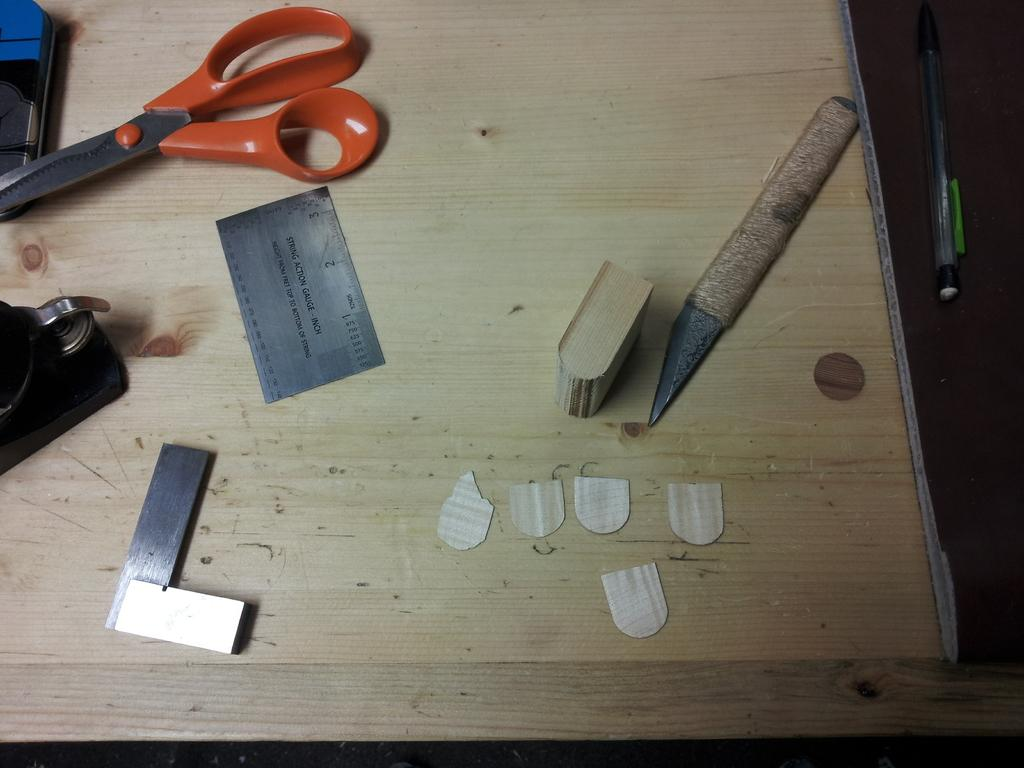What can be seen in the image? There are objects in the image. Can you describe the setting of the image? There is a table in the background of the image. What type of line is used to support the journey in the image? There is no line or journey present in the image; it only contains objects and a table in the background. 